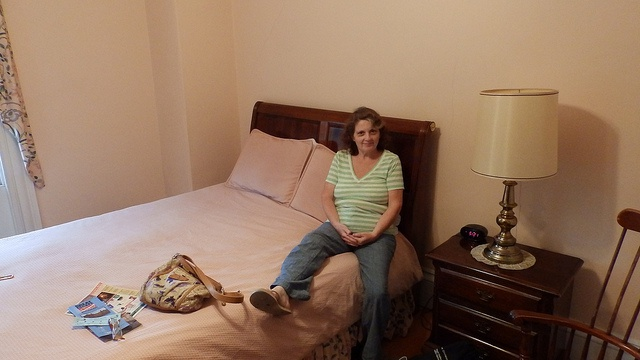Describe the objects in this image and their specific colors. I can see bed in gray, tan, black, and maroon tones, people in gray, black, and tan tones, chair in gray, black, and maroon tones, handbag in gray, maroon, and tan tones, and book in gray and darkgray tones in this image. 